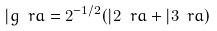Convert formula to latex. <formula><loc_0><loc_0><loc_500><loc_500>| g \ r a = 2 ^ { - 1 / 2 } ( | 2 \ r a + | 3 \ r a )</formula> 